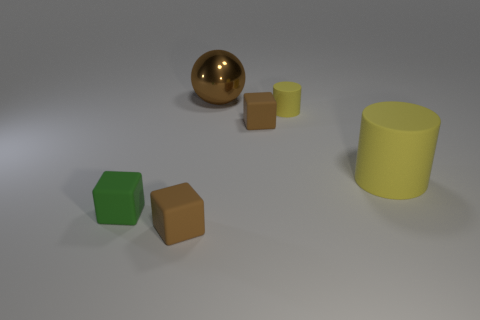Describe the arrangement of the objects. The objects are arranged in a line from left to right with equal spacing: a green cube, a brown cube, a small yellow cylinder, a large golden sphere, and finally a large yellow cylinder.  Does the size of the objects change as you move from left to right? Yes, starting from the left, the green cube is smaller than the brown cube next to it, followed by an even smaller yellow cylinder. The size then increases with the golden sphere and finally peaks with the larger yellow cylinder on the right. 